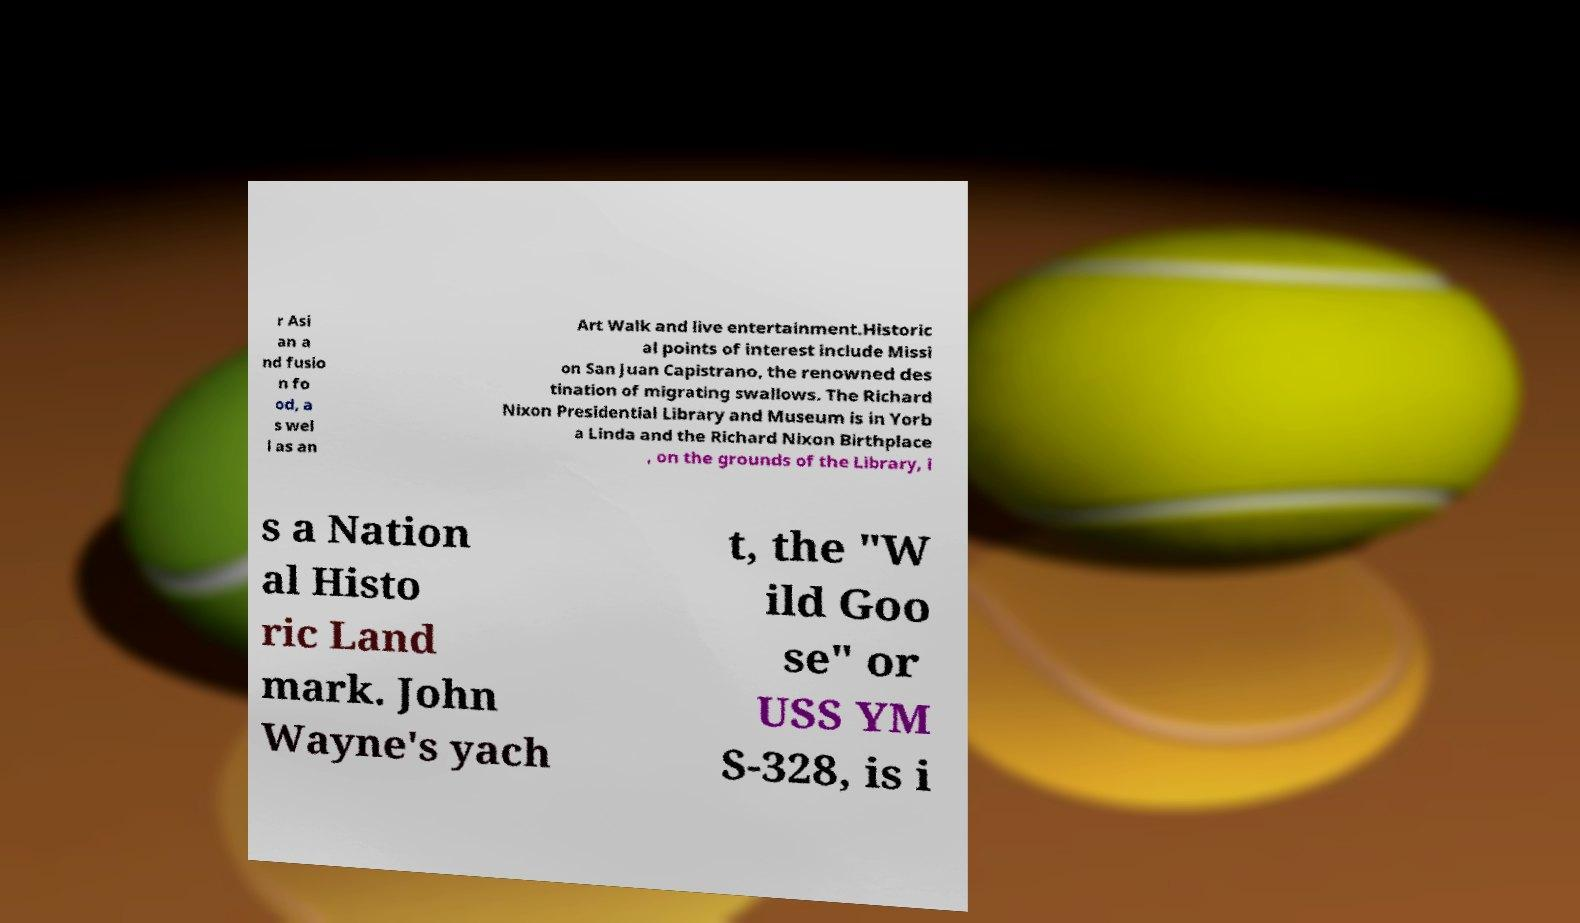For documentation purposes, I need the text within this image transcribed. Could you provide that? r Asi an a nd fusio n fo od, a s wel l as an Art Walk and live entertainment.Historic al points of interest include Missi on San Juan Capistrano, the renowned des tination of migrating swallows. The Richard Nixon Presidential Library and Museum is in Yorb a Linda and the Richard Nixon Birthplace , on the grounds of the Library, i s a Nation al Histo ric Land mark. John Wayne's yach t, the "W ild Goo se" or USS YM S-328, is i 